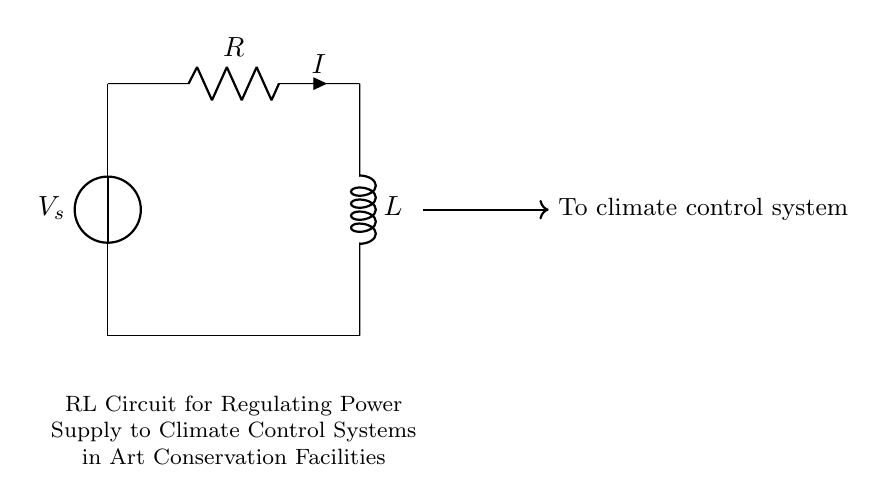What is the voltage source labeled in the circuit? The voltage source is labeled as V_s, which indicates that it is providing the source voltage for the circuit.
Answer: V_s What does the resistor in the circuit represent? The resistor, labeled as R, represents the resistive component of the circuit, which limits the flow of current.
Answer: R What is the purpose of the inductor in this circuit? The inductor, labeled as L, stores energy in the magnetic field created by the current and helps to regulate current flow to the climate control system.
Answer: L How many components are connected in series in this circuit? In this circuit, there are two primary components connected in series, the resistor and the inductor, along with the voltage source.
Answer: Two What is the direction of current flow indicated in the circuit? The current flow is indicated by the arrow labeled as I, showing the conventional current direction from the positive side of the voltage source through the resistor to the inductor.
Answer: From voltage source to inductor If the resistance is increased, what happens to the current in the circuit? If the resistance increases, according to Ohm's Law, the current decreases because current is inversely proportional to resistance, assuming the voltage remains constant.
Answer: Decreases What is the primary application of this RL circuit in the context of art conservation? The primary application is to regulate the power supply to climate control systems in art conservation facilities to ensure stable conditions for preserving artworks.
Answer: Climate control 